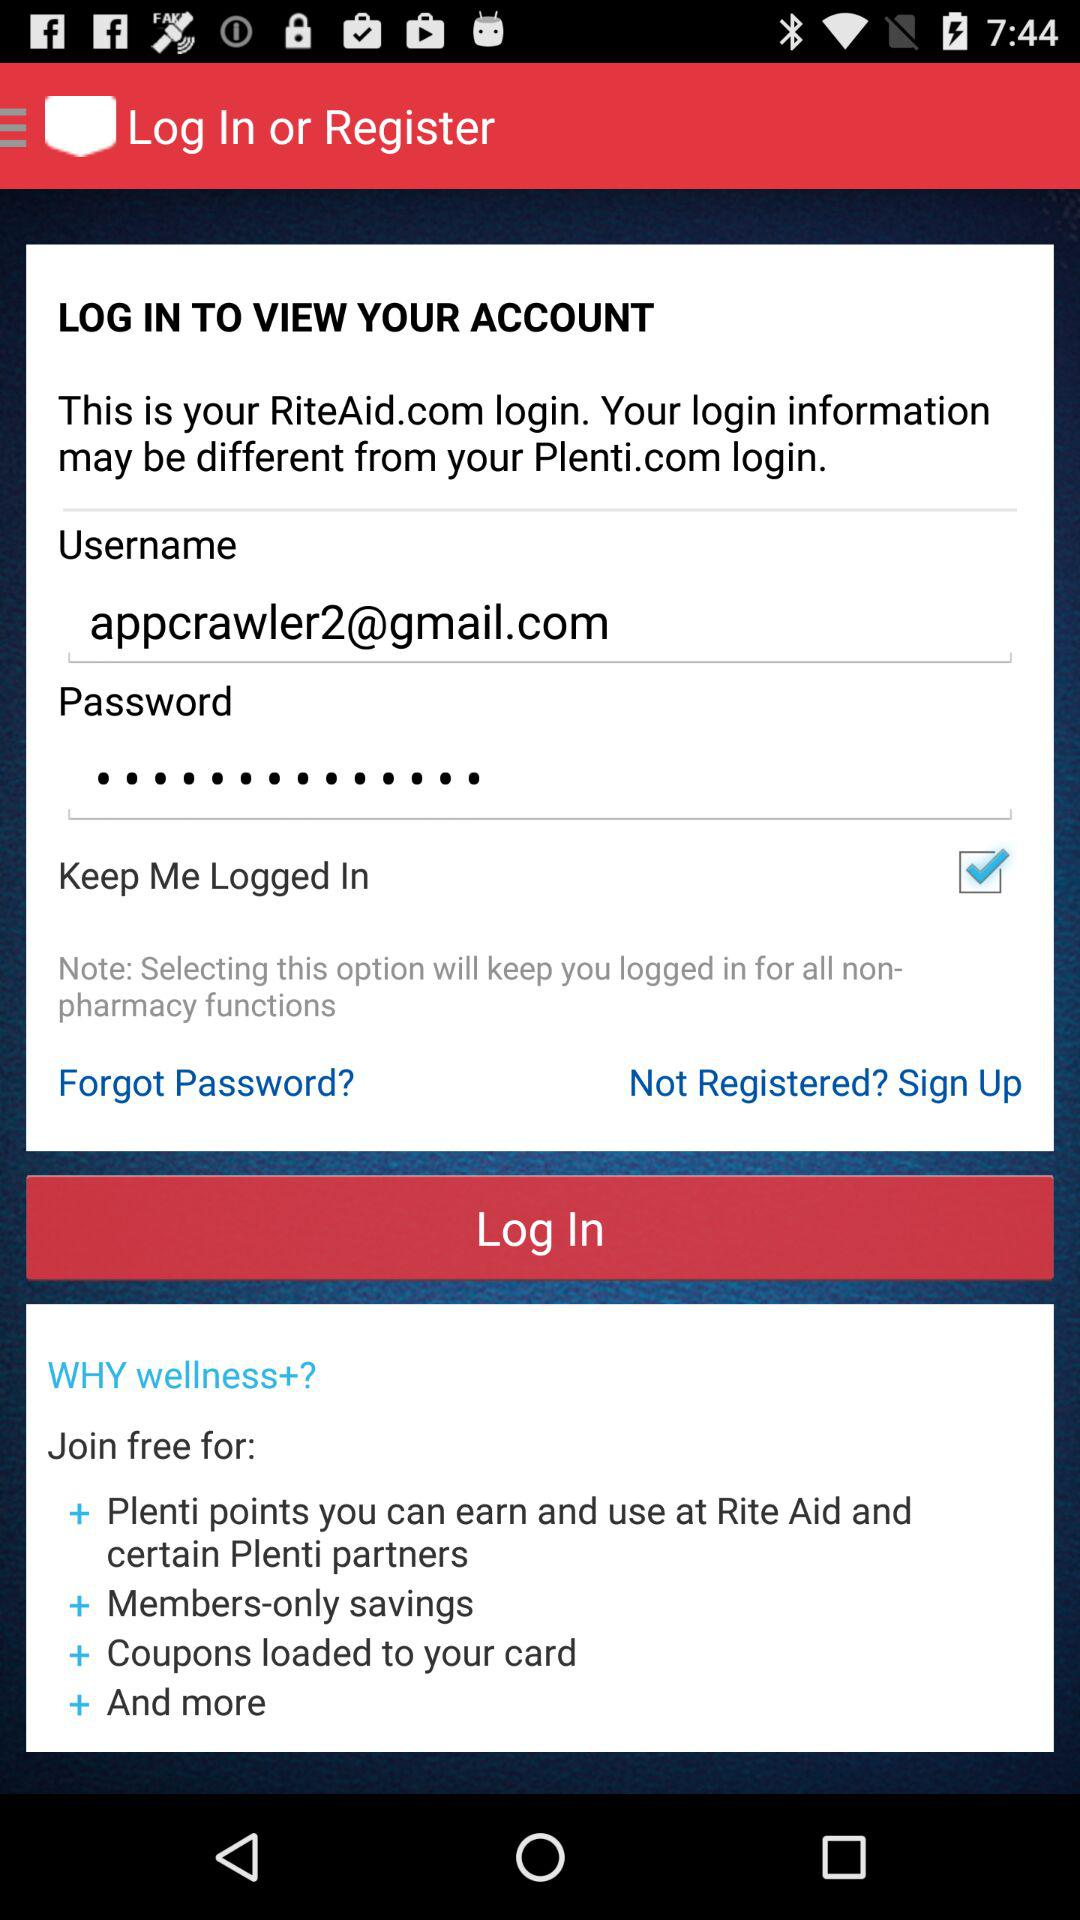What is the status of the "Keep Me Logged In"? The status is on. 